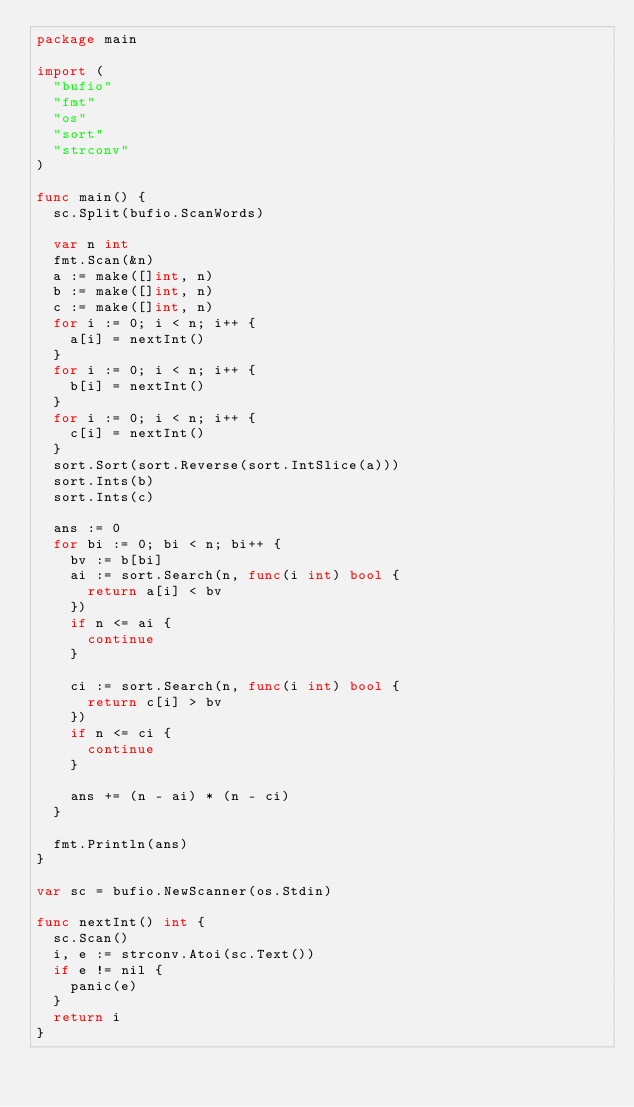Convert code to text. <code><loc_0><loc_0><loc_500><loc_500><_Go_>package main

import (
	"bufio"
	"fmt"
	"os"
	"sort"
	"strconv"
)

func main() {
	sc.Split(bufio.ScanWords)

	var n int
	fmt.Scan(&n)
	a := make([]int, n)
	b := make([]int, n)
	c := make([]int, n)
	for i := 0; i < n; i++ {
		a[i] = nextInt()
	}
	for i := 0; i < n; i++ {
		b[i] = nextInt()
	}
	for i := 0; i < n; i++ {
		c[i] = nextInt()
	}
	sort.Sort(sort.Reverse(sort.IntSlice(a)))
	sort.Ints(b)
	sort.Ints(c)

	ans := 0
	for bi := 0; bi < n; bi++ {
		bv := b[bi]
		ai := sort.Search(n, func(i int) bool {
			return a[i] < bv
		})
		if n <= ai {
			continue
		}

		ci := sort.Search(n, func(i int) bool {
			return c[i] > bv
		})
		if n <= ci {
			continue
		}

		ans += (n - ai) * (n - ci)
	}

	fmt.Println(ans)
}

var sc = bufio.NewScanner(os.Stdin)

func nextInt() int {
	sc.Scan()
	i, e := strconv.Atoi(sc.Text())
	if e != nil {
		panic(e)
	}
	return i
}
</code> 